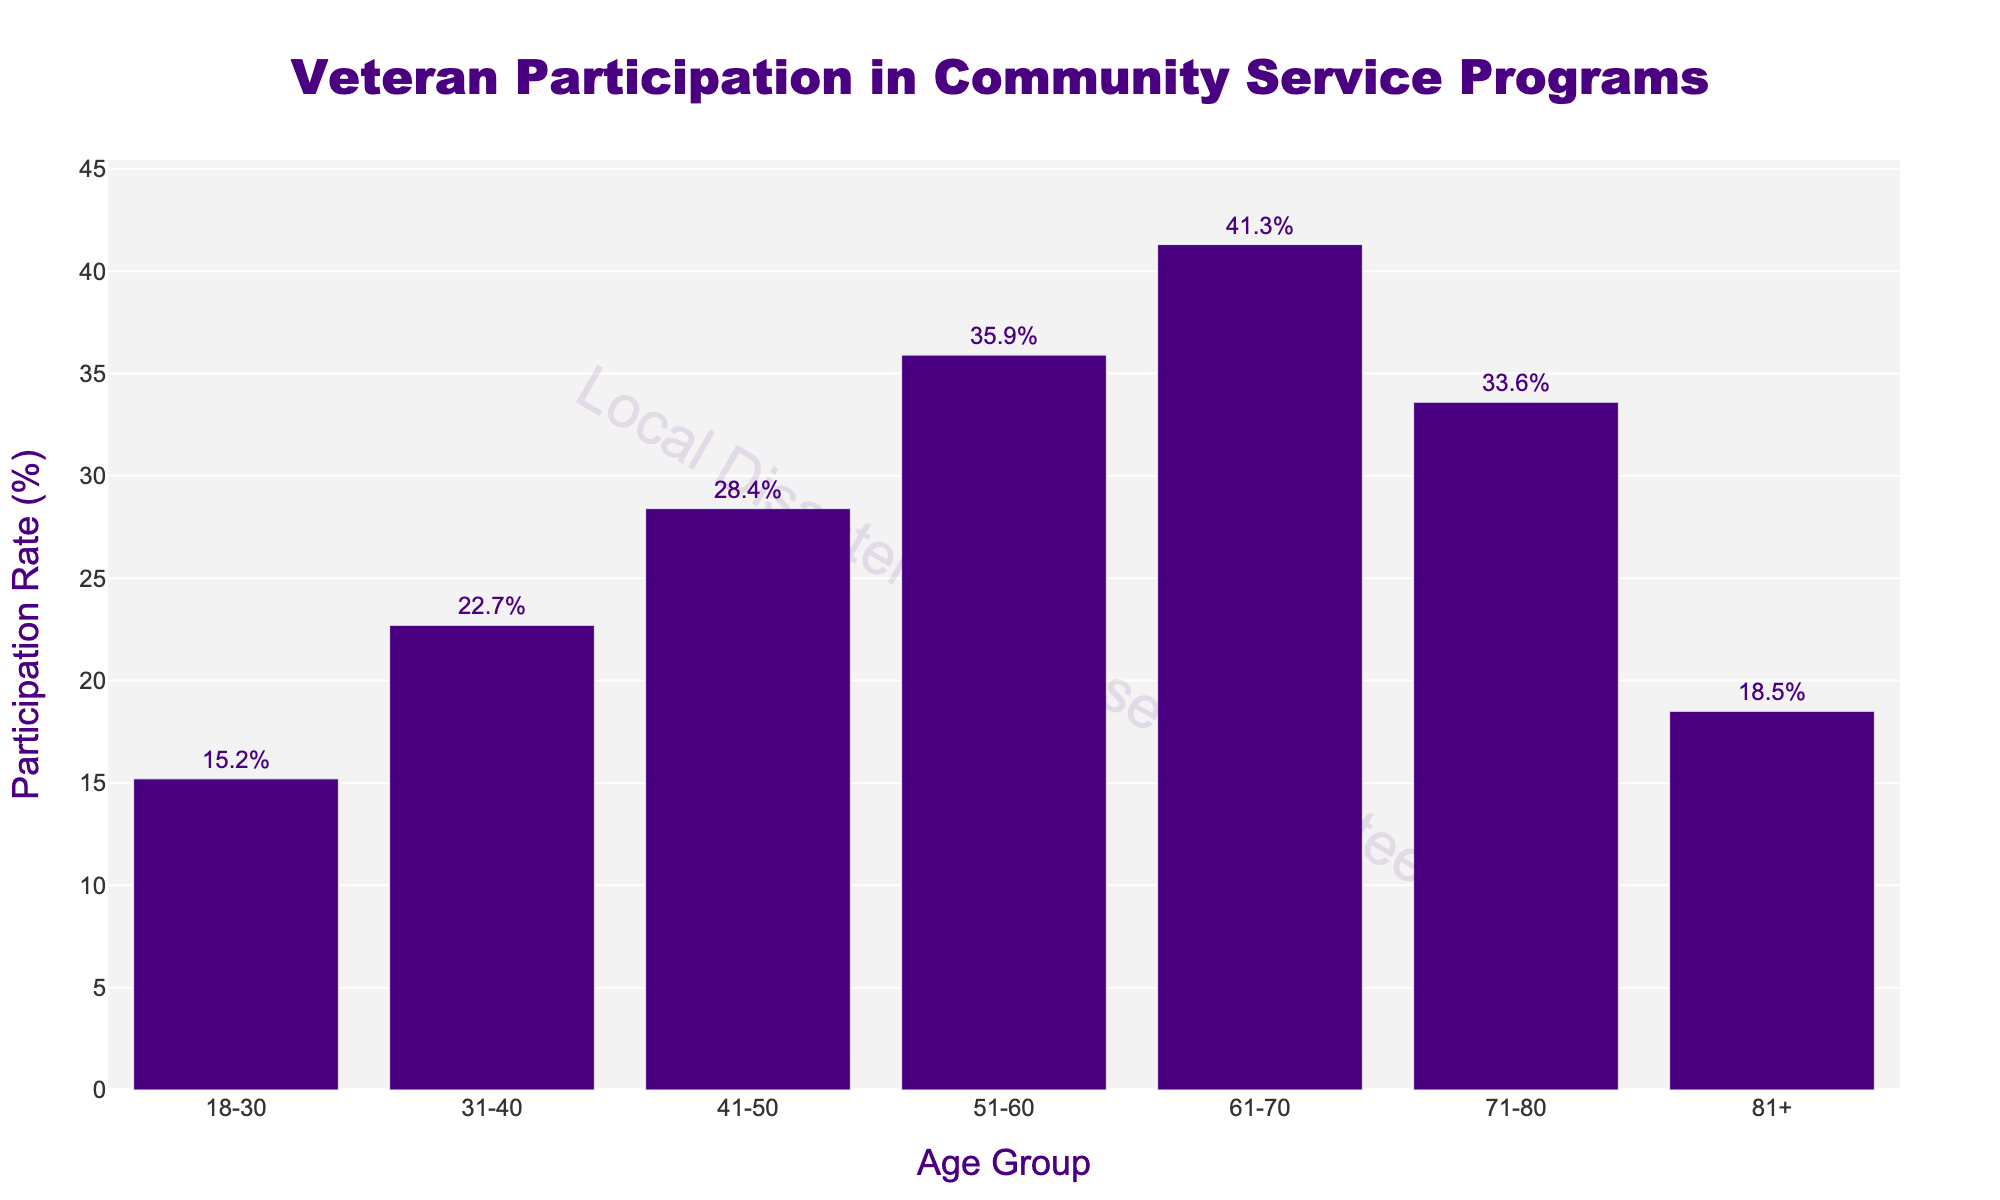Which age group has the highest participation rate? The bar for the 61-70 age group is the tallest, indicating the highest participation rate.
Answer: 61-70 Which age group has the lowest participation rate? The bar for the 18-30 age group is the shortest, indicating the lowest participation rate.
Answer: 18-30 How much greater is the participation rate of the 51-60 age group compared to the 81+ age group? The participation rate for the 51-60 age group is 35.9% and for the 81+ age group is 18.5%. The difference is 35.9 - 18.5 = 17.4%.
Answer: 17.4% What is the average participation rate of the 41-50 and 61-70 age groups? The participation rates are 28.4% for 41-50 and 41.3% for 61-70. The average is (28.4 + 41.3) / 2 = 34.85%.
Answer: 34.85% What is the total participation rate for the age groups under 50? The participation rates are 15.2% (18-30), 22.7% (31-40), and 28.4% (41-50). The sum is 15.2 + 22.7 + 28.4 = 66.3%.
Answer: 66.3% Which two adjacent age groups have the smallest difference in their participation rates? Comparing all adjacent groups: 18-30 & 31-40 (22.7-15.2=7.5), 31-40 & 41-50 (28.4-22.7=5.7), 41-50 & 51-60 (35.9-28.4=7.5), 51-60 & 61-70 (41.3-35.9=5.4), 61-70 & 71-80 (41.3-33.6=7.7), 71-80 & 81+ (33.6-18.5=15.1). The smallest difference is between the 51-60 and 61-70 age groups (5.4%).
Answer: 51-60 and 61-70 By what percentage does the participation rate of the 71-80 age group exceed the 18-30 age group? The participation rates are 33.6% for 71-80 and 15.2% for 18-30. The percentage increase is (33.6 - 15.2) / 15.2 * 100 = 121.05%.
Answer: 121.05% Is the participation rate of the 31-40 age group greater than the combined participation rate of the 18-30 and 81+ age groups? The participation rate for 31-40 is 22.7%. The combined rate for 18-30 and 81+ is 15.2 + 18.5 = 33.7%. 22.7% is less than 33.7%.
Answer: No What is the difference in participation rate between the age groups 51-60 and 71-80? The participation rates are 35.9% for 51-60 and 33.6% for 71-80. The difference is 35.9 - 33.6 = 2.3%.
Answer: 2.3% How does the length of the bar for the 61-70 age group compare to the length of the bar for the 18-30 age group visually? The bar for the 61-70 age group is more than twice as tall as the bar for the 18-30 age group, indicating a significantly higher participation rate.
Answer: More than twice as tall 